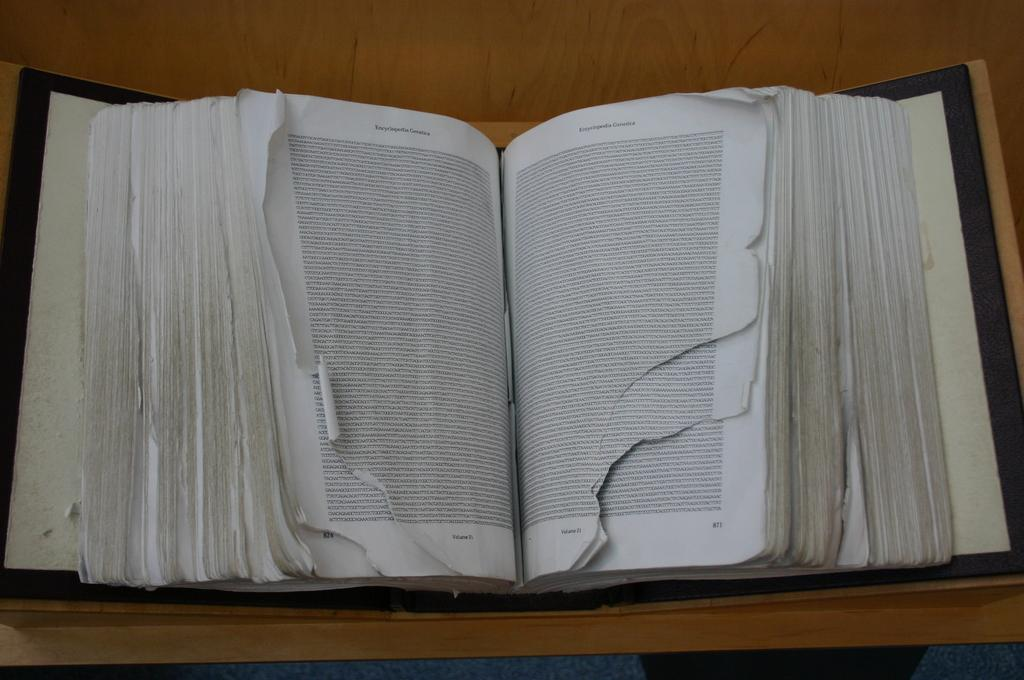What is present on the table in the image? There is a book in the image. Can you describe the state of the book? The book is opened. Where is the book located? The book is placed on a table. How many boys are sitting on the leg of the table in the image? There are no boys present in the image, and the image does not show any legs of the table. 